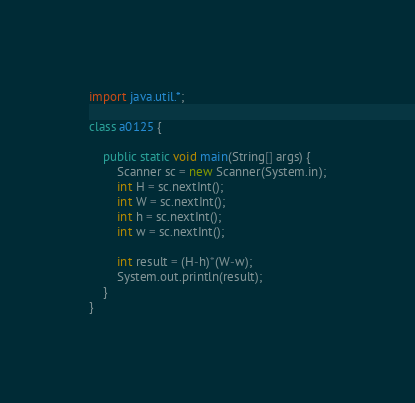<code> <loc_0><loc_0><loc_500><loc_500><_Java_>import java.util.*;
 
class a0125 {
 
    public static void main(String[] args) {
        Scanner sc = new Scanner(System.in);
        int H = sc.nextInt();
        int W = sc.nextInt();
        int h = sc.nextInt();
        int w = sc.nextInt();
 
        int result = (H-h)*(W-w);
        System.out.println(result);
    }
}</code> 